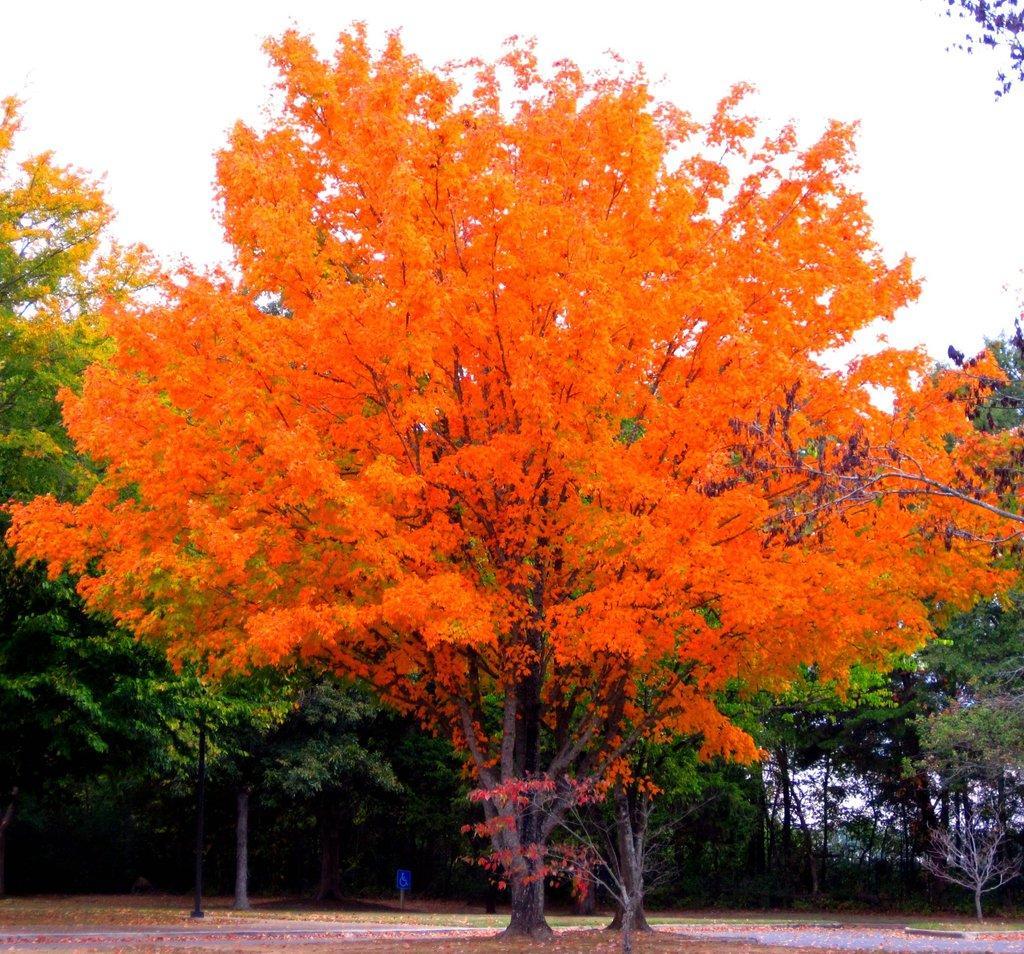Could you give a brief overview of what you see in this image? In this image we can see some trees, and a pole, also we can see the sky. 